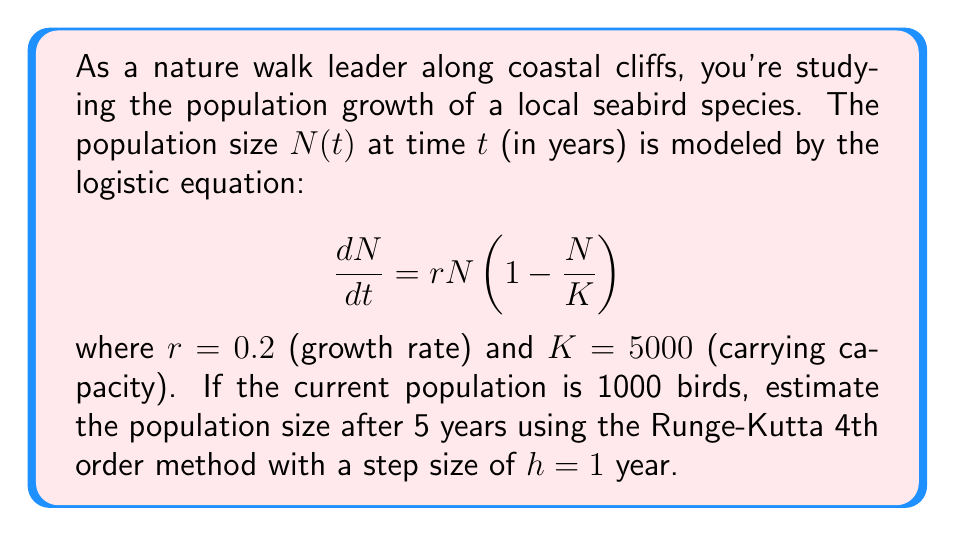Can you answer this question? To solve this problem, we'll use the Runge-Kutta 4th order method (RK4) to approximate the solution of the differential equation. The RK4 method is given by:

$$N_{n+1} = N_n + \frac{1}{6}(k_1 + 2k_2 + 2k_3 + k_4)$$

where:
$$\begin{align*}
k_1 &= hf(t_n, N_n) \\
k_2 &= hf(t_n + \frac{h}{2}, N_n + \frac{k_1}{2}) \\
k_3 &= hf(t_n + \frac{h}{2}, N_n + \frac{k_2}{2}) \\
k_4 &= hf(t_n + h, N_n + k_3)
\end{align*}$$

In our case, $f(t, N) = rN(1 - \frac{N}{K}) = 0.2N(1 - \frac{N}{5000})$

Let's calculate the population for each year:

Year 0 (initial): $N_0 = 1000$

Year 1:
$$\begin{align*}
k_1 &= 1 \cdot 0.2 \cdot 1000 \cdot (1 - \frac{1000}{5000}) = 160 \\
k_2 &= 1 \cdot 0.2 \cdot (1000 + 80) \cdot (1 - \frac{1080}{5000}) = 165.888 \\
k_3 &= 1 \cdot 0.2 \cdot (1000 + 82.944) \cdot (1 - \frac{1082.944}{5000}) = 166.173 \\
k_4 &= 1 \cdot 0.2 \cdot (1000 + 166.173) \cdot (1 - \frac{1166.173}{5000}) = 171.234
\end{align*}$$

$N_1 = 1000 + \frac{1}{6}(160 + 2(165.888) + 2(166.173) + 171.234) = 1165.893$

Repeating this process for the remaining years:

Year 2: $N_2 = 1349.656$
Year 3: $N_3 = 1549.008$
Year 4: $N_4 = 1761.220$
Year 5: $N_5 = 1983.173$
Answer: The estimated population size after 5 years is approximately 1983 seabirds. 